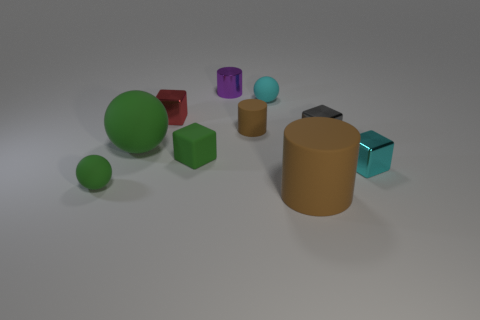Does the purple cylinder have the same size as the green matte object that is on the right side of the red cube?
Make the answer very short. Yes. What number of objects are cubes left of the large brown matte thing or tiny green things that are in front of the small cyan cube?
Give a very brief answer. 3. The red metallic thing that is the same size as the cyan metal cube is what shape?
Your response must be concise. Cube. There is a brown rubber thing behind the large object that is in front of the tiny ball that is on the left side of the shiny cylinder; what shape is it?
Give a very brief answer. Cylinder. Are there an equal number of gray objects in front of the matte cube and red metal things?
Offer a very short reply. No. Do the metal cylinder and the cyan sphere have the same size?
Give a very brief answer. Yes. How many metal objects are either brown objects or small blue cylinders?
Make the answer very short. 0. What material is the brown thing that is the same size as the red metal cube?
Give a very brief answer. Rubber. How many other objects are the same material as the tiny purple cylinder?
Give a very brief answer. 3. Are there fewer small matte blocks on the right side of the big brown cylinder than small green matte things?
Provide a succinct answer. Yes. 